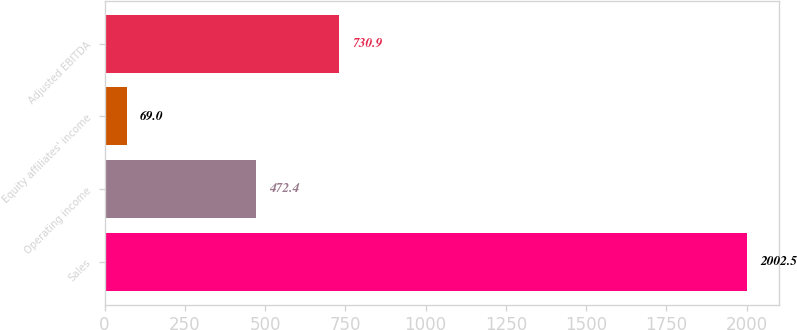Convert chart. <chart><loc_0><loc_0><loc_500><loc_500><bar_chart><fcel>Sales<fcel>Operating income<fcel>Equity affiliates' income<fcel>Adjusted EBITDA<nl><fcel>2002.5<fcel>472.4<fcel>69<fcel>730.9<nl></chart> 